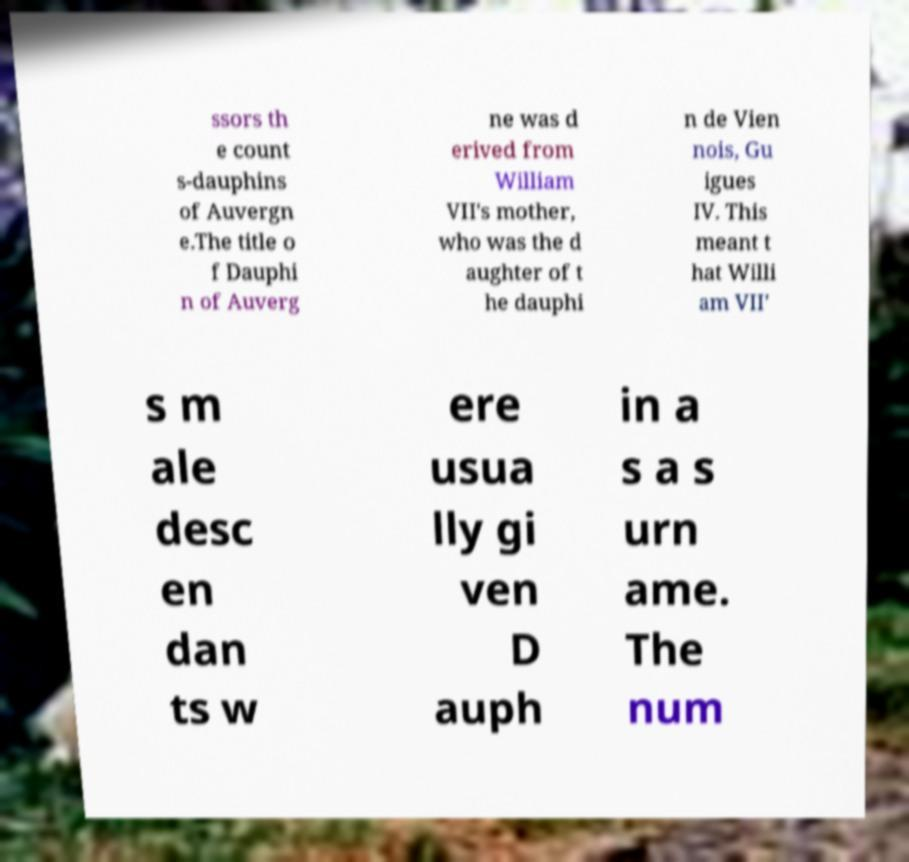Please read and relay the text visible in this image. What does it say? ssors th e count s-dauphins of Auvergn e.The title o f Dauphi n of Auverg ne was d erived from William VII's mother, who was the d aughter of t he dauphi n de Vien nois, Gu igues IV. This meant t hat Willi am VII' s m ale desc en dan ts w ere usua lly gi ven D auph in a s a s urn ame. The num 